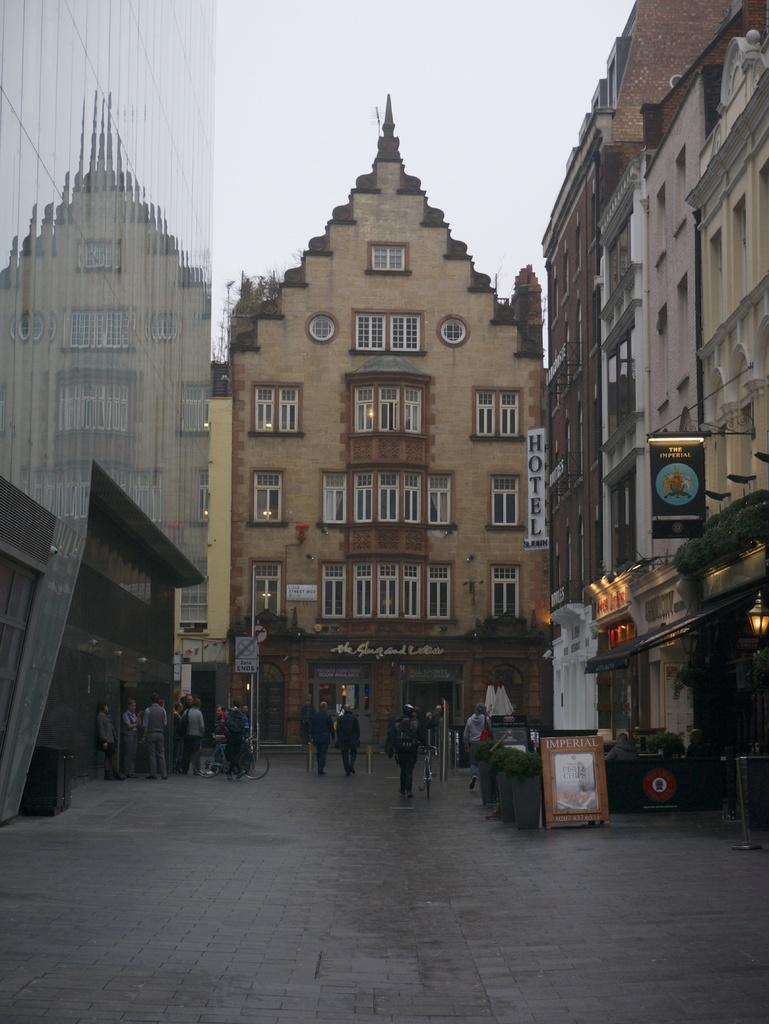What are the people in the image doing? The people in the image are walking on the street. Where is the street located in the image? The street is at the bottom of the image. What else can be seen in the image besides the street? There are buildings in the image. What is visible at the top of the image? The sky is visible at the top of the image. Can you see a snail crawling on the buildings in the image? There is no snail present in the image; it only features people walking on the street and buildings. 